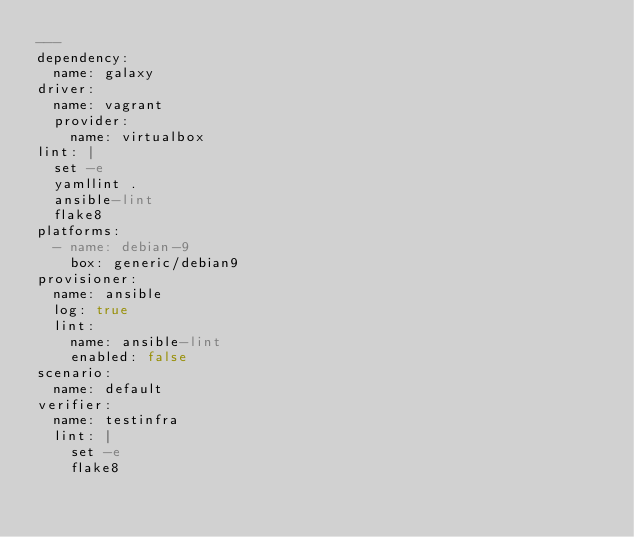Convert code to text. <code><loc_0><loc_0><loc_500><loc_500><_YAML_>---
dependency:
  name: galaxy
driver:
  name: vagrant
  provider:
    name: virtualbox
lint: |
  set -e
  yamllint .
  ansible-lint
  flake8
platforms:
  - name: debian-9
    box: generic/debian9
provisioner:
  name: ansible
  log: true
  lint:
    name: ansible-lint
    enabled: false
scenario:
  name: default
verifier:
  name: testinfra
  lint: |
    set -e
    flake8
</code> 